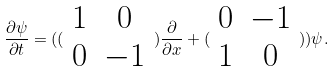<formula> <loc_0><loc_0><loc_500><loc_500>\frac { \partial \psi } { \partial t } = ( ( \begin{array} { c c } 1 & 0 \\ 0 & - 1 \end{array} ) \frac { \partial } { \partial x } + ( \begin{array} { c c } 0 & - 1 \\ 1 & 0 \end{array} ) ) \psi .</formula> 